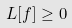Convert formula to latex. <formula><loc_0><loc_0><loc_500><loc_500>L [ f ] \geq 0</formula> 